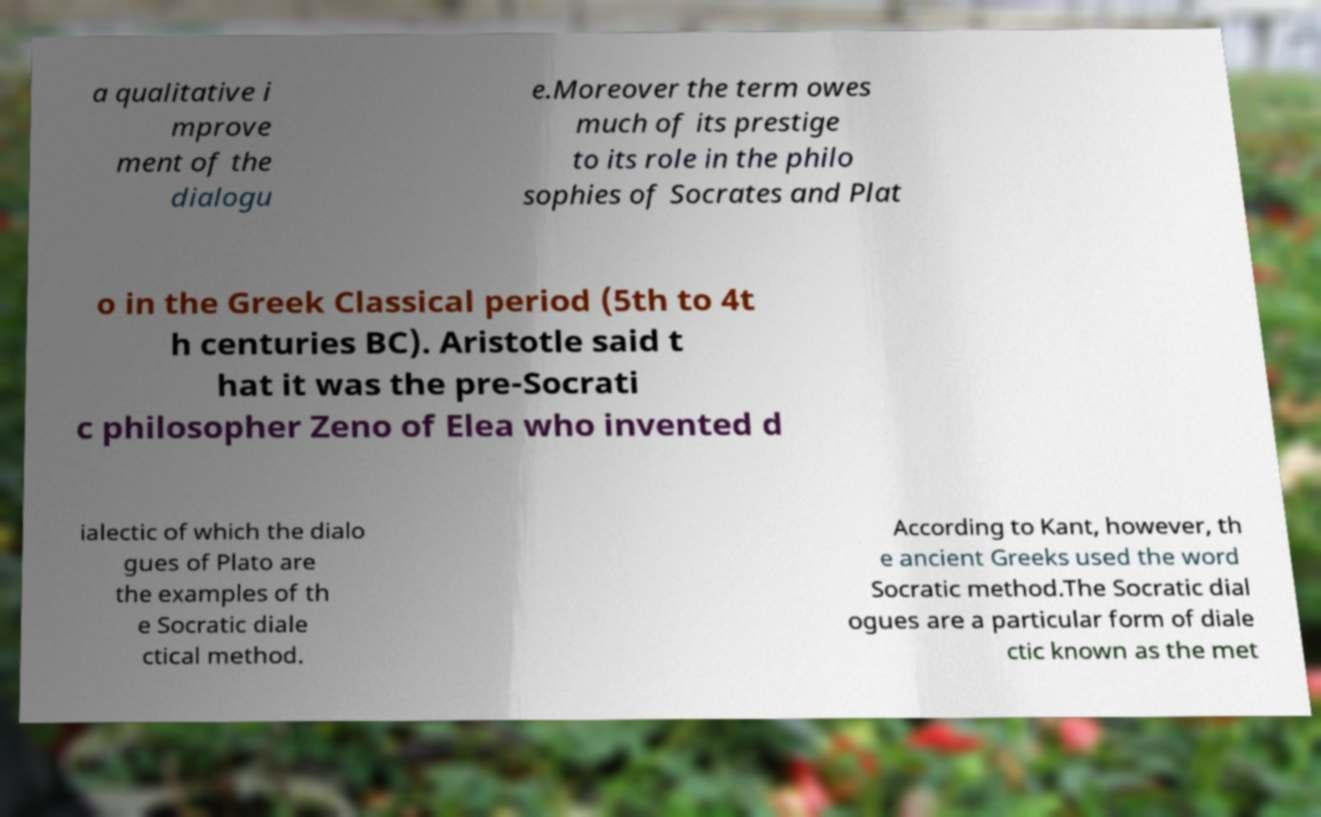Could you extract and type out the text from this image? a qualitative i mprove ment of the dialogu e.Moreover the term owes much of its prestige to its role in the philo sophies of Socrates and Plat o in the Greek Classical period (5th to 4t h centuries BC). Aristotle said t hat it was the pre-Socrati c philosopher Zeno of Elea who invented d ialectic of which the dialo gues of Plato are the examples of th e Socratic diale ctical method. According to Kant, however, th e ancient Greeks used the word Socratic method.The Socratic dial ogues are a particular form of diale ctic known as the met 